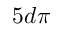Convert formula to latex. <formula><loc_0><loc_0><loc_500><loc_500>5 d \pi</formula> 